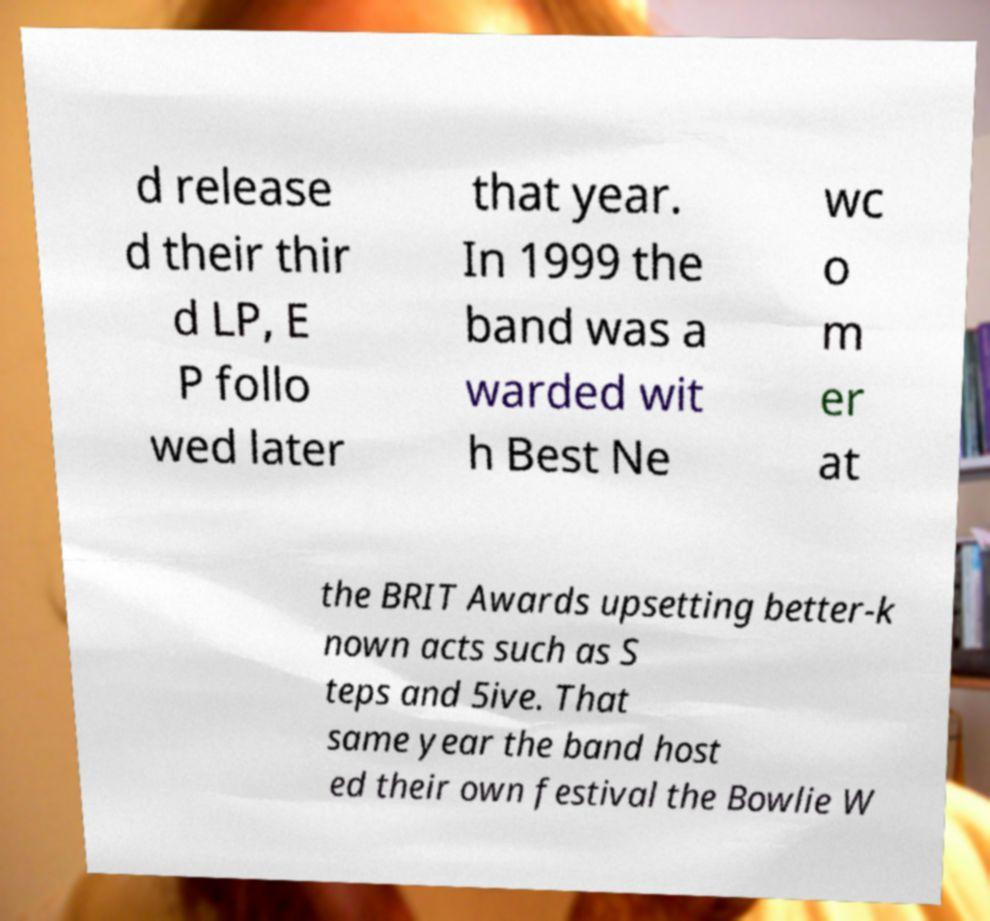Can you read and provide the text displayed in the image?This photo seems to have some interesting text. Can you extract and type it out for me? d release d their thir d LP, E P follo wed later that year. In 1999 the band was a warded wit h Best Ne wc o m er at the BRIT Awards upsetting better-k nown acts such as S teps and 5ive. That same year the band host ed their own festival the Bowlie W 